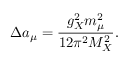<formula> <loc_0><loc_0><loc_500><loc_500>\Delta a _ { \mu } = { \frac { g _ { X } ^ { 2 } m _ { \mu } ^ { 2 } } { 1 2 \pi ^ { 2 } M _ { X } ^ { 2 } } } .</formula> 